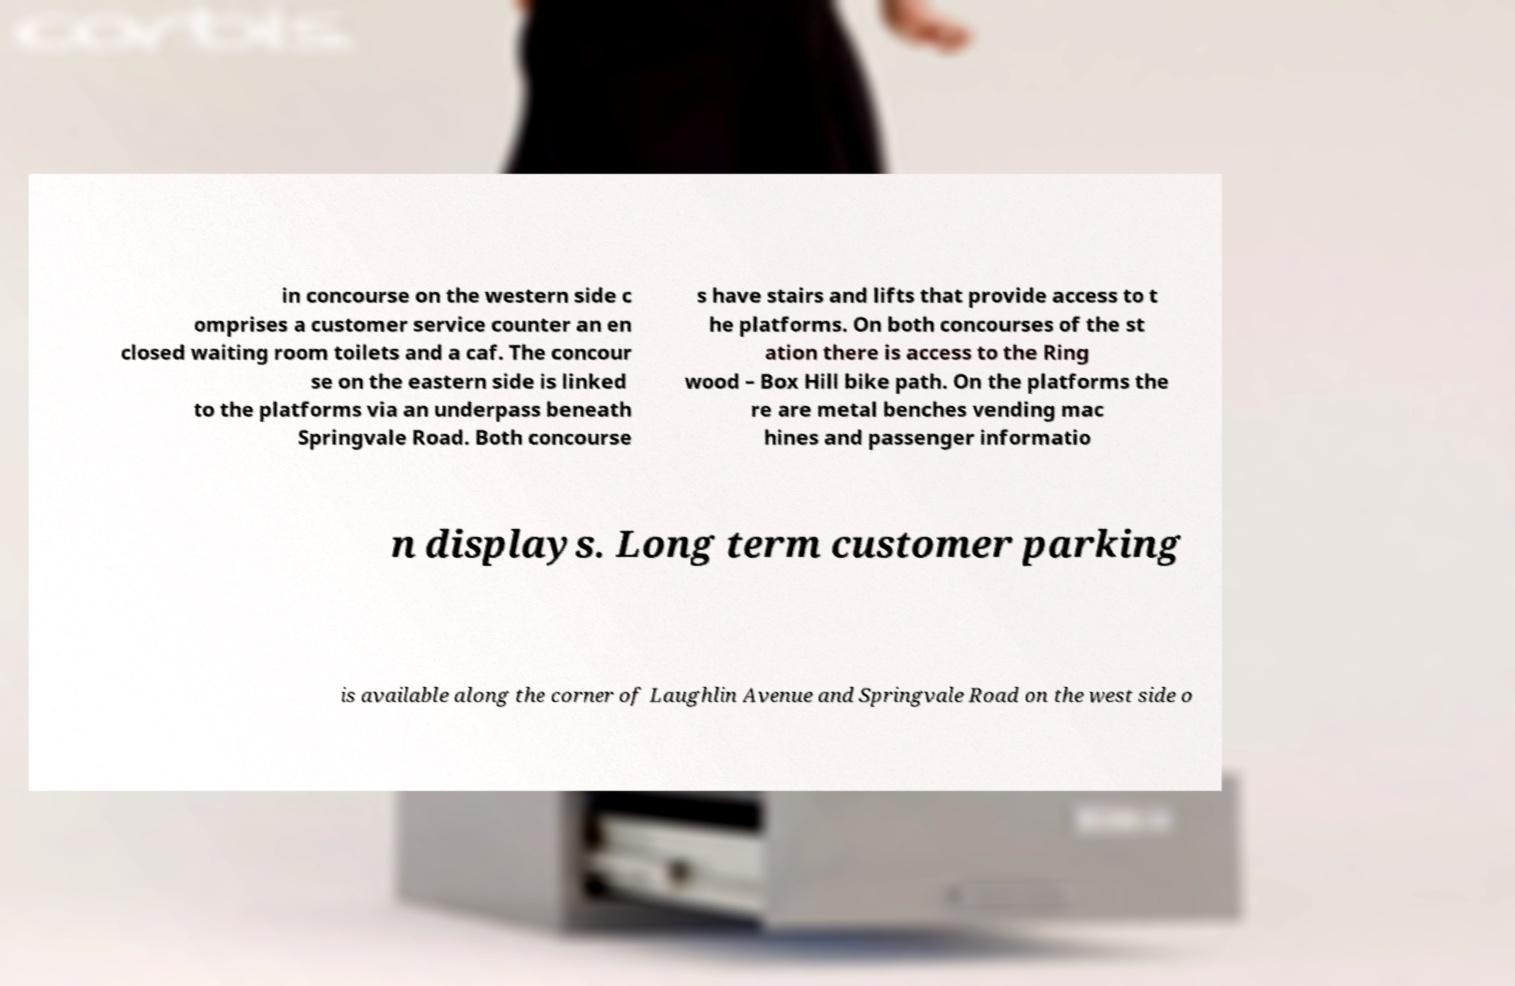I need the written content from this picture converted into text. Can you do that? in concourse on the western side c omprises a customer service counter an en closed waiting room toilets and a caf. The concour se on the eastern side is linked to the platforms via an underpass beneath Springvale Road. Both concourse s have stairs and lifts that provide access to t he platforms. On both concourses of the st ation there is access to the Ring wood – Box Hill bike path. On the platforms the re are metal benches vending mac hines and passenger informatio n displays. Long term customer parking is available along the corner of Laughlin Avenue and Springvale Road on the west side o 